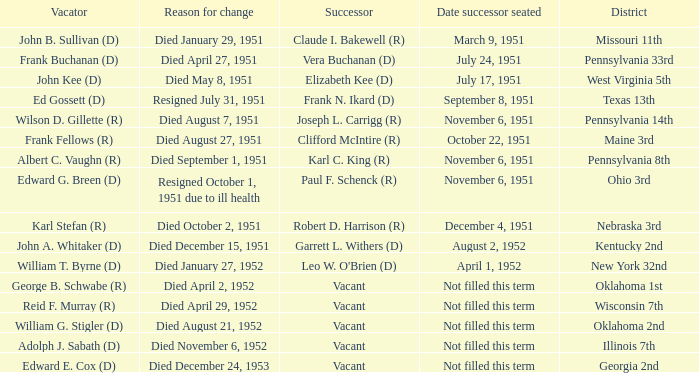Who was the successor for the Kentucky 2nd district? Garrett L. Withers (D). 